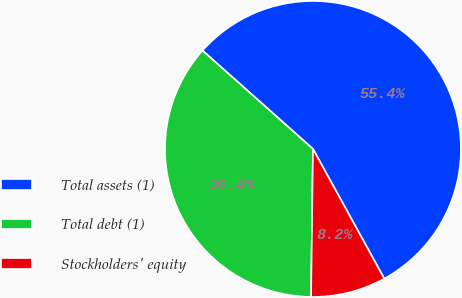Convert chart. <chart><loc_0><loc_0><loc_500><loc_500><pie_chart><fcel>Total assets (1)<fcel>Total debt (1)<fcel>Stockholders' equity<nl><fcel>55.42%<fcel>36.38%<fcel>8.21%<nl></chart> 